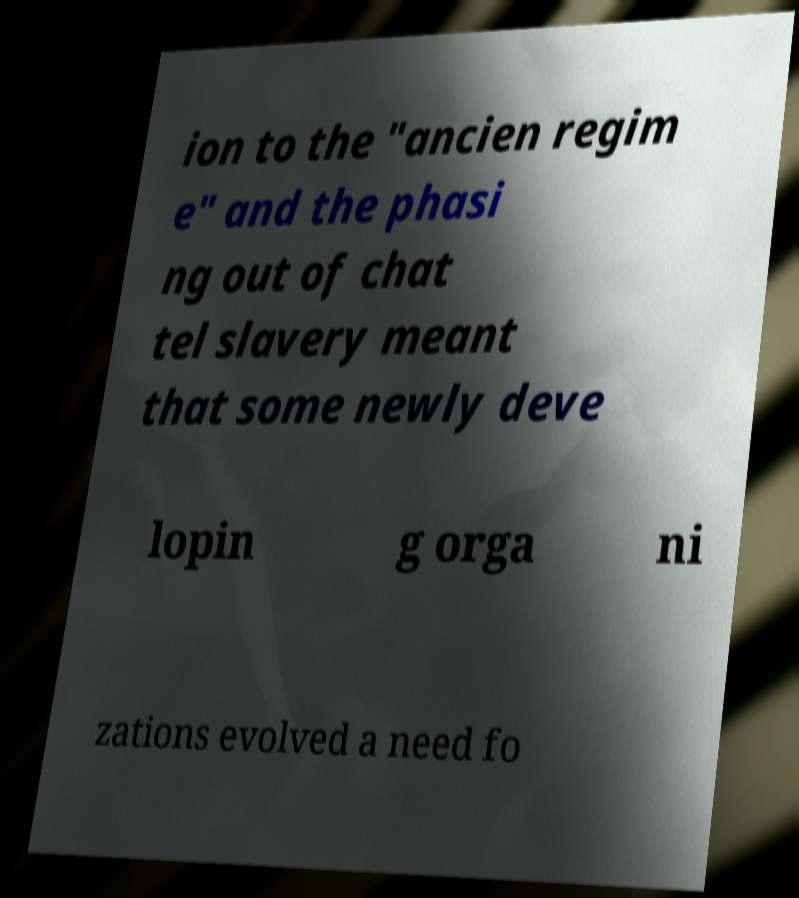Can you accurately transcribe the text from the provided image for me? ion to the "ancien regim e" and the phasi ng out of chat tel slavery meant that some newly deve lopin g orga ni zations evolved a need fo 